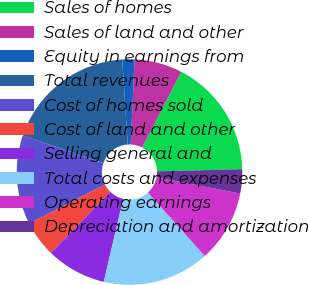Convert chart to OTSL. <chart><loc_0><loc_0><loc_500><loc_500><pie_chart><fcel>Sales of homes<fcel>Sales of land and other<fcel>Equity in earnings from<fcel>Total revenues<fcel>Cost of homes sold<fcel>Cost of land and other<fcel>Selling general and<fcel>Total costs and expenses<fcel>Operating earnings<fcel>Depreciation and amortization<nl><fcel>17.01%<fcel>6.88%<fcel>1.74%<fcel>18.72%<fcel>12.82%<fcel>5.17%<fcel>8.6%<fcel>15.29%<fcel>10.31%<fcel>3.45%<nl></chart> 